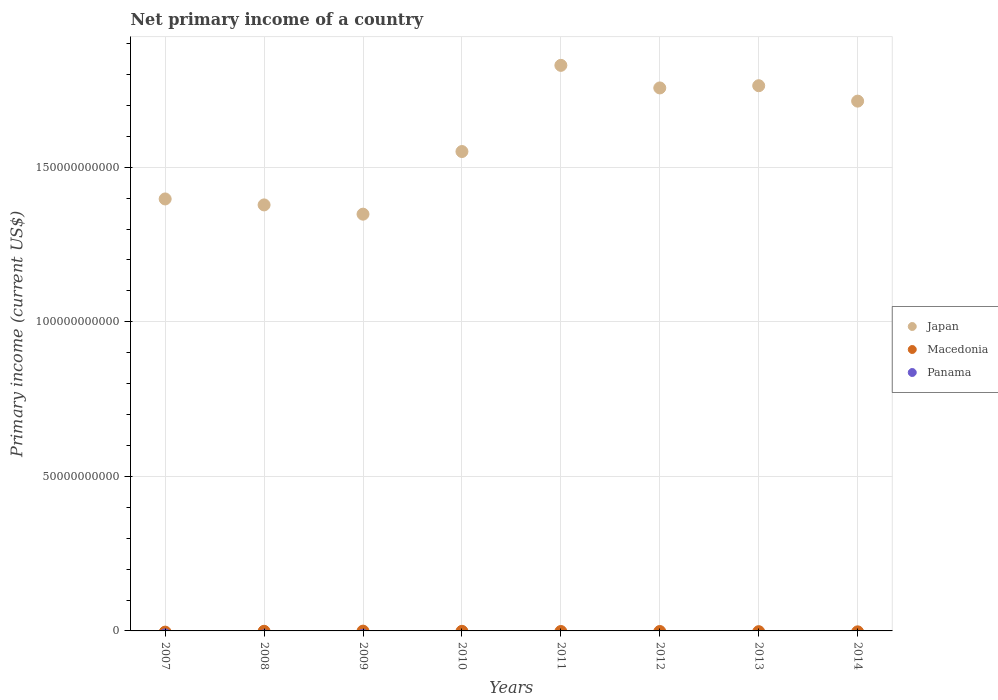Is the number of dotlines equal to the number of legend labels?
Keep it short and to the point. No. What is the primary income in Panama in 2007?
Offer a terse response. 0. Across all years, what is the maximum primary income in Japan?
Offer a very short reply. 1.83e+11. Across all years, what is the minimum primary income in Panama?
Keep it short and to the point. 0. What is the total primary income in Macedonia in the graph?
Your answer should be compact. 0. What is the difference between the primary income in Japan in 2007 and that in 2009?
Provide a short and direct response. 4.92e+09. What is the difference between the primary income in Japan in 2014 and the primary income in Panama in 2012?
Provide a succinct answer. 1.71e+11. In how many years, is the primary income in Japan greater than 90000000000 US$?
Give a very brief answer. 8. What is the ratio of the primary income in Japan in 2007 to that in 2010?
Provide a succinct answer. 0.9. What is the difference between the highest and the second highest primary income in Japan?
Your response must be concise. 6.59e+09. What is the difference between the highest and the lowest primary income in Japan?
Ensure brevity in your answer.  4.81e+1. In how many years, is the primary income in Japan greater than the average primary income in Japan taken over all years?
Your answer should be compact. 4. Is it the case that in every year, the sum of the primary income in Macedonia and primary income in Panama  is greater than the primary income in Japan?
Offer a very short reply. No. Is the primary income in Japan strictly greater than the primary income in Panama over the years?
Make the answer very short. Yes. How many dotlines are there?
Keep it short and to the point. 1. Does the graph contain any zero values?
Ensure brevity in your answer.  Yes. Where does the legend appear in the graph?
Your response must be concise. Center right. What is the title of the graph?
Offer a very short reply. Net primary income of a country. Does "Japan" appear as one of the legend labels in the graph?
Your response must be concise. Yes. What is the label or title of the X-axis?
Ensure brevity in your answer.  Years. What is the label or title of the Y-axis?
Your response must be concise. Primary income (current US$). What is the Primary income (current US$) of Japan in 2007?
Give a very brief answer. 1.40e+11. What is the Primary income (current US$) of Macedonia in 2007?
Your response must be concise. 0. What is the Primary income (current US$) of Panama in 2007?
Ensure brevity in your answer.  0. What is the Primary income (current US$) of Japan in 2008?
Give a very brief answer. 1.38e+11. What is the Primary income (current US$) of Japan in 2009?
Ensure brevity in your answer.  1.35e+11. What is the Primary income (current US$) in Japan in 2010?
Make the answer very short. 1.55e+11. What is the Primary income (current US$) in Japan in 2011?
Offer a very short reply. 1.83e+11. What is the Primary income (current US$) in Macedonia in 2011?
Keep it short and to the point. 0. What is the Primary income (current US$) in Panama in 2011?
Your response must be concise. 0. What is the Primary income (current US$) in Japan in 2012?
Your answer should be very brief. 1.76e+11. What is the Primary income (current US$) of Panama in 2012?
Provide a succinct answer. 0. What is the Primary income (current US$) of Japan in 2013?
Offer a terse response. 1.76e+11. What is the Primary income (current US$) in Macedonia in 2013?
Offer a terse response. 0. What is the Primary income (current US$) in Japan in 2014?
Provide a succinct answer. 1.71e+11. Across all years, what is the maximum Primary income (current US$) in Japan?
Your answer should be very brief. 1.83e+11. Across all years, what is the minimum Primary income (current US$) of Japan?
Make the answer very short. 1.35e+11. What is the total Primary income (current US$) in Japan in the graph?
Your answer should be very brief. 1.27e+12. What is the total Primary income (current US$) in Macedonia in the graph?
Ensure brevity in your answer.  0. What is the total Primary income (current US$) of Panama in the graph?
Your response must be concise. 0. What is the difference between the Primary income (current US$) in Japan in 2007 and that in 2008?
Make the answer very short. 1.93e+09. What is the difference between the Primary income (current US$) of Japan in 2007 and that in 2009?
Provide a succinct answer. 4.92e+09. What is the difference between the Primary income (current US$) in Japan in 2007 and that in 2010?
Your answer should be compact. -1.53e+1. What is the difference between the Primary income (current US$) in Japan in 2007 and that in 2011?
Your answer should be very brief. -4.32e+1. What is the difference between the Primary income (current US$) in Japan in 2007 and that in 2012?
Make the answer very short. -3.59e+1. What is the difference between the Primary income (current US$) in Japan in 2007 and that in 2013?
Provide a short and direct response. -3.66e+1. What is the difference between the Primary income (current US$) of Japan in 2007 and that in 2014?
Your response must be concise. -3.16e+1. What is the difference between the Primary income (current US$) in Japan in 2008 and that in 2009?
Keep it short and to the point. 3.00e+09. What is the difference between the Primary income (current US$) of Japan in 2008 and that in 2010?
Provide a short and direct response. -1.73e+1. What is the difference between the Primary income (current US$) in Japan in 2008 and that in 2011?
Your answer should be very brief. -4.51e+1. What is the difference between the Primary income (current US$) of Japan in 2008 and that in 2012?
Give a very brief answer. -3.78e+1. What is the difference between the Primary income (current US$) in Japan in 2008 and that in 2013?
Your answer should be compact. -3.86e+1. What is the difference between the Primary income (current US$) in Japan in 2008 and that in 2014?
Offer a terse response. -3.36e+1. What is the difference between the Primary income (current US$) in Japan in 2009 and that in 2010?
Ensure brevity in your answer.  -2.03e+1. What is the difference between the Primary income (current US$) in Japan in 2009 and that in 2011?
Provide a succinct answer. -4.81e+1. What is the difference between the Primary income (current US$) of Japan in 2009 and that in 2012?
Your answer should be compact. -4.08e+1. What is the difference between the Primary income (current US$) of Japan in 2009 and that in 2013?
Offer a terse response. -4.16e+1. What is the difference between the Primary income (current US$) in Japan in 2009 and that in 2014?
Your answer should be compact. -3.66e+1. What is the difference between the Primary income (current US$) of Japan in 2010 and that in 2011?
Your answer should be very brief. -2.79e+1. What is the difference between the Primary income (current US$) in Japan in 2010 and that in 2012?
Offer a very short reply. -2.06e+1. What is the difference between the Primary income (current US$) in Japan in 2010 and that in 2013?
Your answer should be compact. -2.13e+1. What is the difference between the Primary income (current US$) in Japan in 2010 and that in 2014?
Your answer should be compact. -1.63e+1. What is the difference between the Primary income (current US$) in Japan in 2011 and that in 2012?
Offer a terse response. 7.31e+09. What is the difference between the Primary income (current US$) of Japan in 2011 and that in 2013?
Provide a succinct answer. 6.59e+09. What is the difference between the Primary income (current US$) of Japan in 2011 and that in 2014?
Offer a terse response. 1.16e+1. What is the difference between the Primary income (current US$) in Japan in 2012 and that in 2013?
Your response must be concise. -7.19e+08. What is the difference between the Primary income (current US$) in Japan in 2012 and that in 2014?
Offer a terse response. 4.27e+09. What is the difference between the Primary income (current US$) in Japan in 2013 and that in 2014?
Offer a terse response. 4.99e+09. What is the average Primary income (current US$) of Japan per year?
Offer a very short reply. 1.59e+11. What is the average Primary income (current US$) of Macedonia per year?
Provide a succinct answer. 0. What is the average Primary income (current US$) in Panama per year?
Your answer should be very brief. 0. What is the ratio of the Primary income (current US$) in Japan in 2007 to that in 2009?
Ensure brevity in your answer.  1.04. What is the ratio of the Primary income (current US$) of Japan in 2007 to that in 2010?
Ensure brevity in your answer.  0.9. What is the ratio of the Primary income (current US$) in Japan in 2007 to that in 2011?
Ensure brevity in your answer.  0.76. What is the ratio of the Primary income (current US$) in Japan in 2007 to that in 2012?
Provide a succinct answer. 0.8. What is the ratio of the Primary income (current US$) of Japan in 2007 to that in 2013?
Provide a short and direct response. 0.79. What is the ratio of the Primary income (current US$) in Japan in 2007 to that in 2014?
Your response must be concise. 0.82. What is the ratio of the Primary income (current US$) of Japan in 2008 to that in 2009?
Ensure brevity in your answer.  1.02. What is the ratio of the Primary income (current US$) in Japan in 2008 to that in 2010?
Give a very brief answer. 0.89. What is the ratio of the Primary income (current US$) in Japan in 2008 to that in 2011?
Your response must be concise. 0.75. What is the ratio of the Primary income (current US$) in Japan in 2008 to that in 2012?
Your answer should be compact. 0.78. What is the ratio of the Primary income (current US$) of Japan in 2008 to that in 2013?
Offer a very short reply. 0.78. What is the ratio of the Primary income (current US$) in Japan in 2008 to that in 2014?
Ensure brevity in your answer.  0.8. What is the ratio of the Primary income (current US$) of Japan in 2009 to that in 2010?
Offer a terse response. 0.87. What is the ratio of the Primary income (current US$) of Japan in 2009 to that in 2011?
Offer a terse response. 0.74. What is the ratio of the Primary income (current US$) of Japan in 2009 to that in 2012?
Offer a terse response. 0.77. What is the ratio of the Primary income (current US$) in Japan in 2009 to that in 2013?
Offer a very short reply. 0.76. What is the ratio of the Primary income (current US$) of Japan in 2009 to that in 2014?
Ensure brevity in your answer.  0.79. What is the ratio of the Primary income (current US$) of Japan in 2010 to that in 2011?
Your answer should be very brief. 0.85. What is the ratio of the Primary income (current US$) of Japan in 2010 to that in 2012?
Your response must be concise. 0.88. What is the ratio of the Primary income (current US$) in Japan in 2010 to that in 2013?
Offer a terse response. 0.88. What is the ratio of the Primary income (current US$) of Japan in 2010 to that in 2014?
Your answer should be compact. 0.9. What is the ratio of the Primary income (current US$) of Japan in 2011 to that in 2012?
Offer a very short reply. 1.04. What is the ratio of the Primary income (current US$) of Japan in 2011 to that in 2013?
Provide a short and direct response. 1.04. What is the ratio of the Primary income (current US$) in Japan in 2011 to that in 2014?
Give a very brief answer. 1.07. What is the ratio of the Primary income (current US$) in Japan in 2012 to that in 2014?
Give a very brief answer. 1.02. What is the ratio of the Primary income (current US$) in Japan in 2013 to that in 2014?
Keep it short and to the point. 1.03. What is the difference between the highest and the second highest Primary income (current US$) in Japan?
Keep it short and to the point. 6.59e+09. What is the difference between the highest and the lowest Primary income (current US$) of Japan?
Make the answer very short. 4.81e+1. 